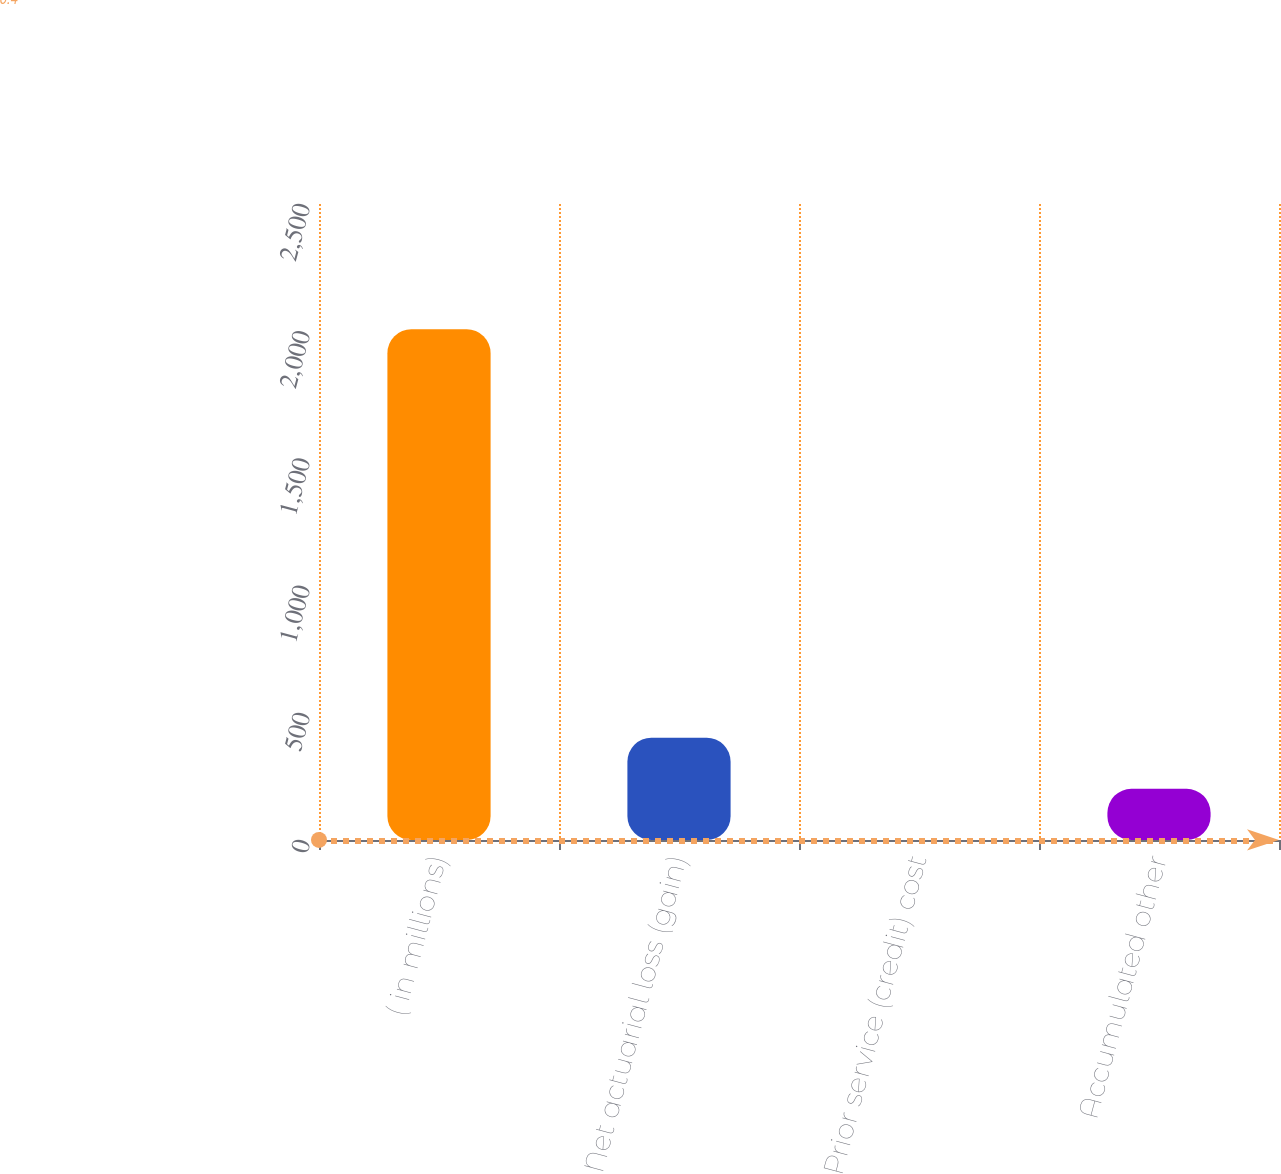Convert chart to OTSL. <chart><loc_0><loc_0><loc_500><loc_500><bar_chart><fcel>( in millions)<fcel>Net actuarial loss (gain)<fcel>Prior service (credit) cost<fcel>Accumulated other<nl><fcel>2008<fcel>401.92<fcel>0.4<fcel>201.16<nl></chart> 